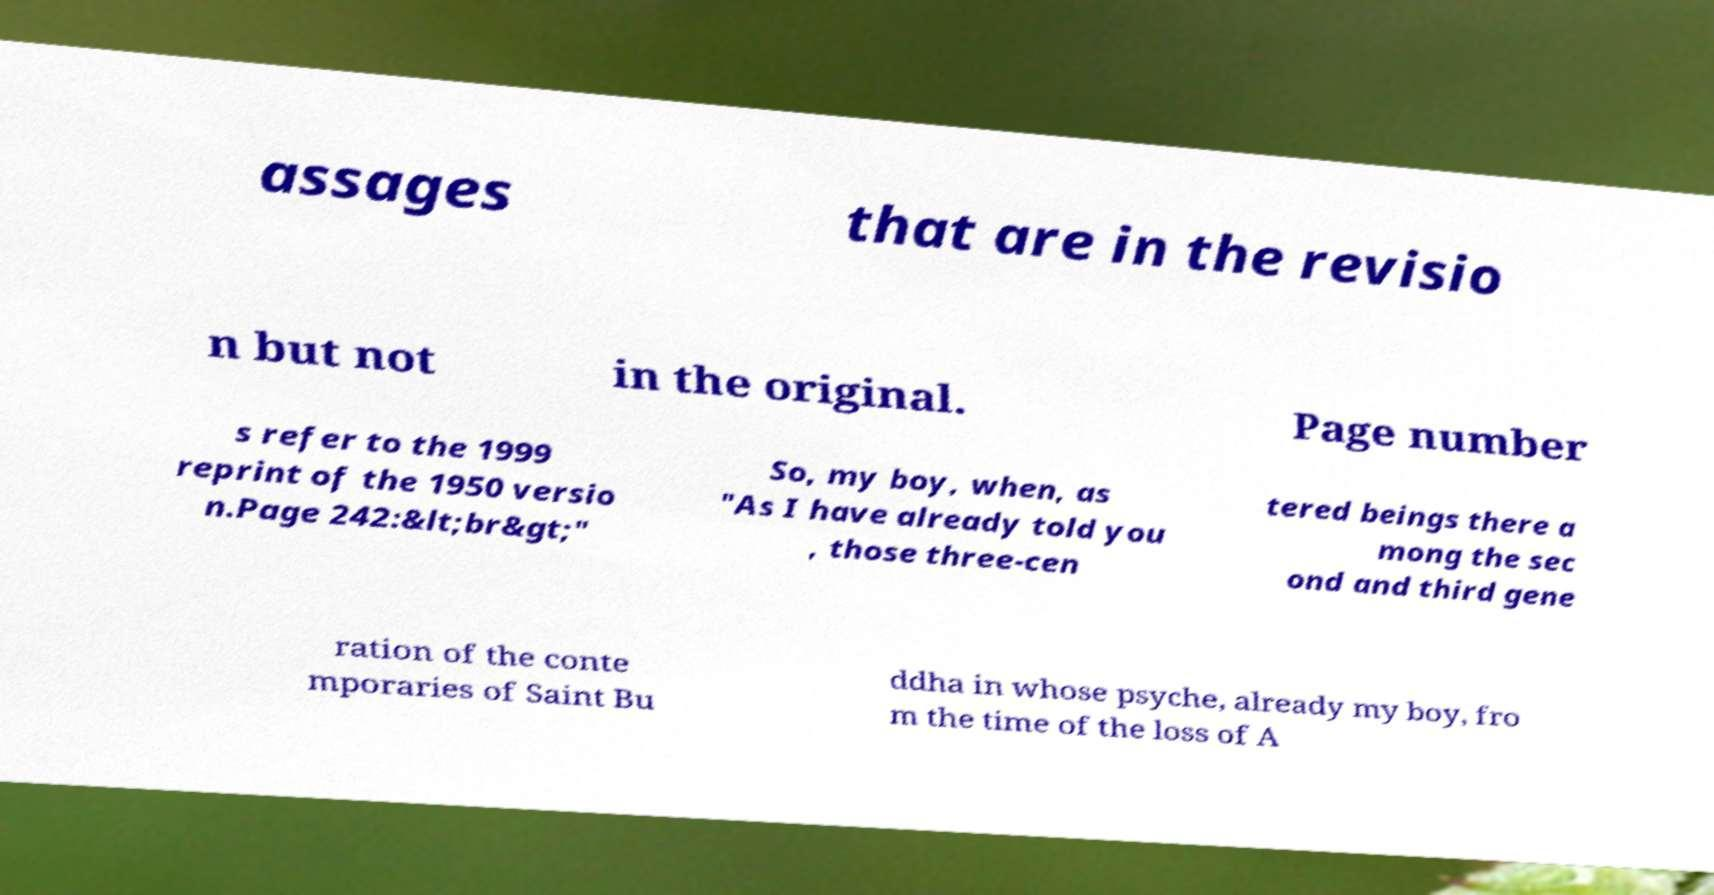I need the written content from this picture converted into text. Can you do that? assages that are in the revisio n but not in the original. Page number s refer to the 1999 reprint of the 1950 versio n.Page 242:&lt;br&gt;" So, my boy, when, as "As I have already told you , those three-cen tered beings there a mong the sec ond and third gene ration of the conte mporaries of Saint Bu ddha in whose psyche, already my boy, fro m the time of the loss of A 